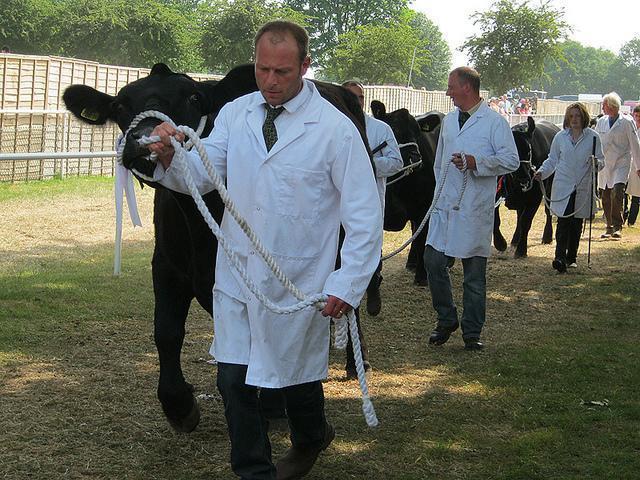How many people can be seen?
Give a very brief answer. 5. How many cows are there?
Give a very brief answer. 3. How many tracks have a train on them?
Give a very brief answer. 0. 